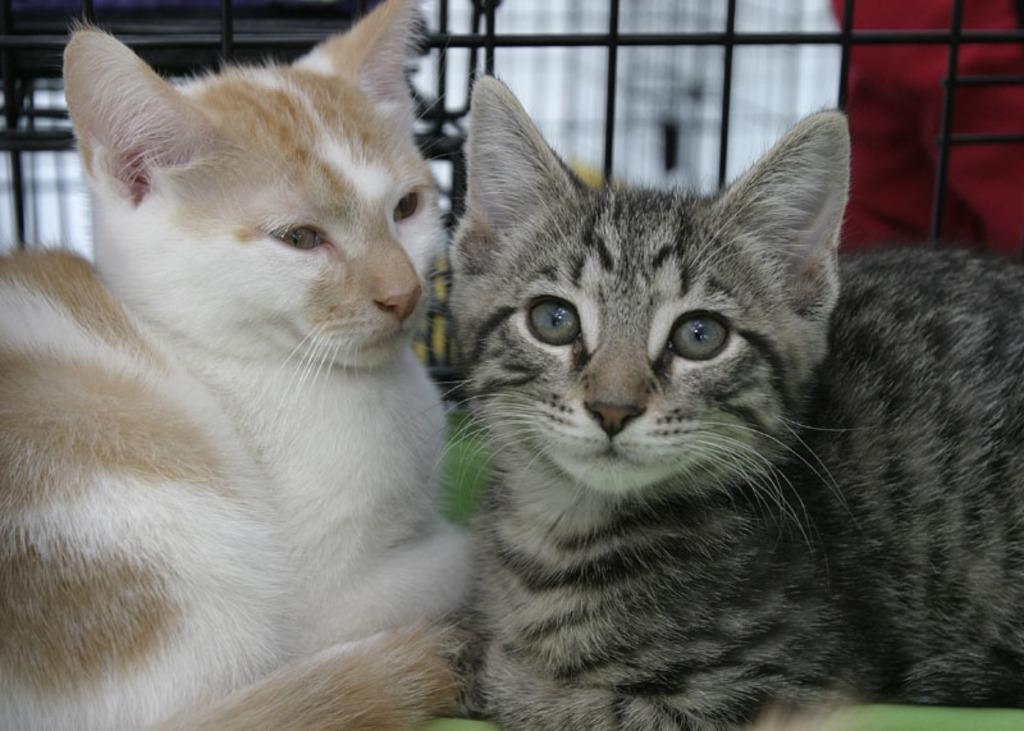How many cats are present in the image? There are two cats in the image. What surface are the cats on? The cats are on a green surface. What can be seen in the background of the image? There are rods visible in the background of the image. How would you describe the background of the image? The background appears blurry. What type of punishment is being administered to the cats in the image? There is no punishment being administered to the cats in the image; they are simply sitting on a green surface. Can you see any rays of light in the image? There is no mention of rays of light in the image; it only describes the presence of cats, a green surface, rods in the background, and a blurry background. 